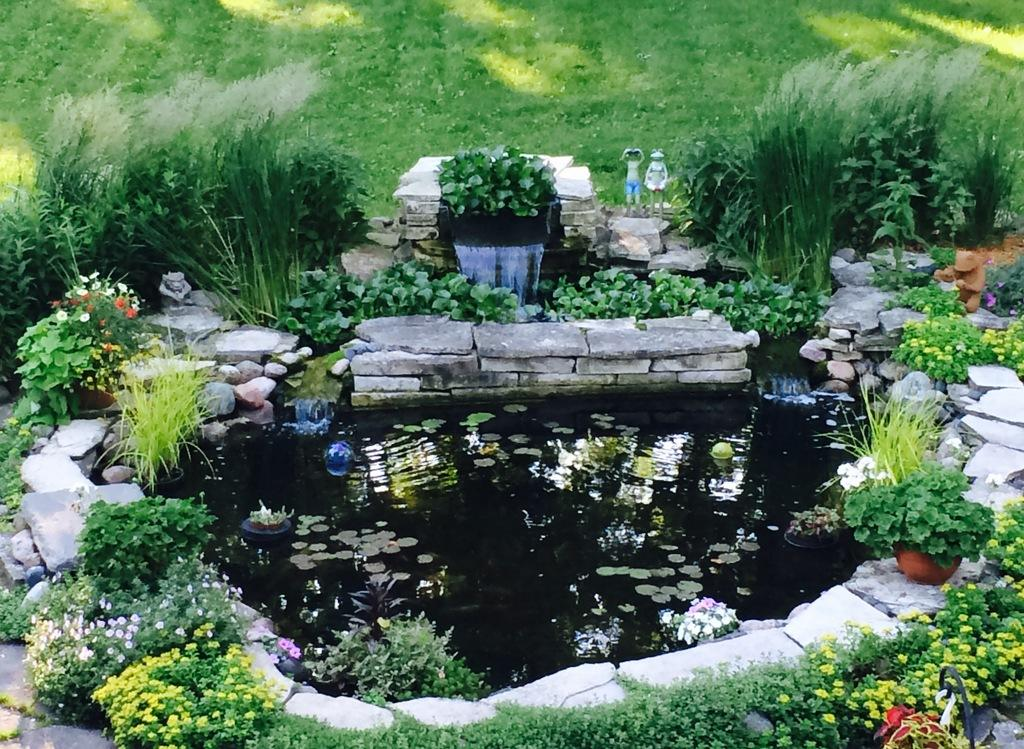What type of body of water is present in the image? There is a pond in the image. What can be found inside the pond? There are leaves and flowers in the pond. Are there any plants or flowers near the pond? Yes, there are flowers around the pond and plants around the pond. What else can be found near the pond? There are rocks around the pond. What is visible in the background of the image? There is a grassy surface visible in the background of the image. What type of comb can be seen in the image? There is no comb present in the image. What reward is being given to the person in the image? There is no person or reward visible in the image; it features a pond with various objects and plants around it. 